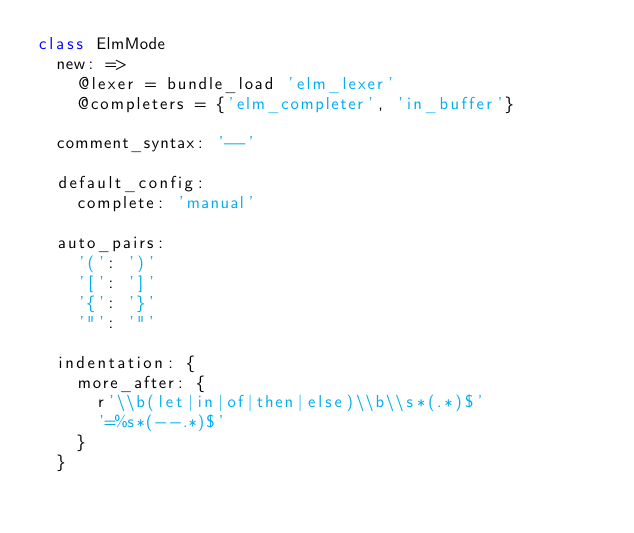<code> <loc_0><loc_0><loc_500><loc_500><_MoonScript_>class ElmMode
  new: =>
    @lexer = bundle_load 'elm_lexer'
    @completers = {'elm_completer', 'in_buffer'}

  comment_syntax: '--'

  default_config:
    complete: 'manual'

  auto_pairs:
    '(': ')'
    '[': ']'
    '{': '}'
    '"': '"'

  indentation: {
    more_after: {
      r'\\b(let|in|of|then|else)\\b\\s*(.*)$'
      '=%s*(--.*)$'
    }
  }
</code> 